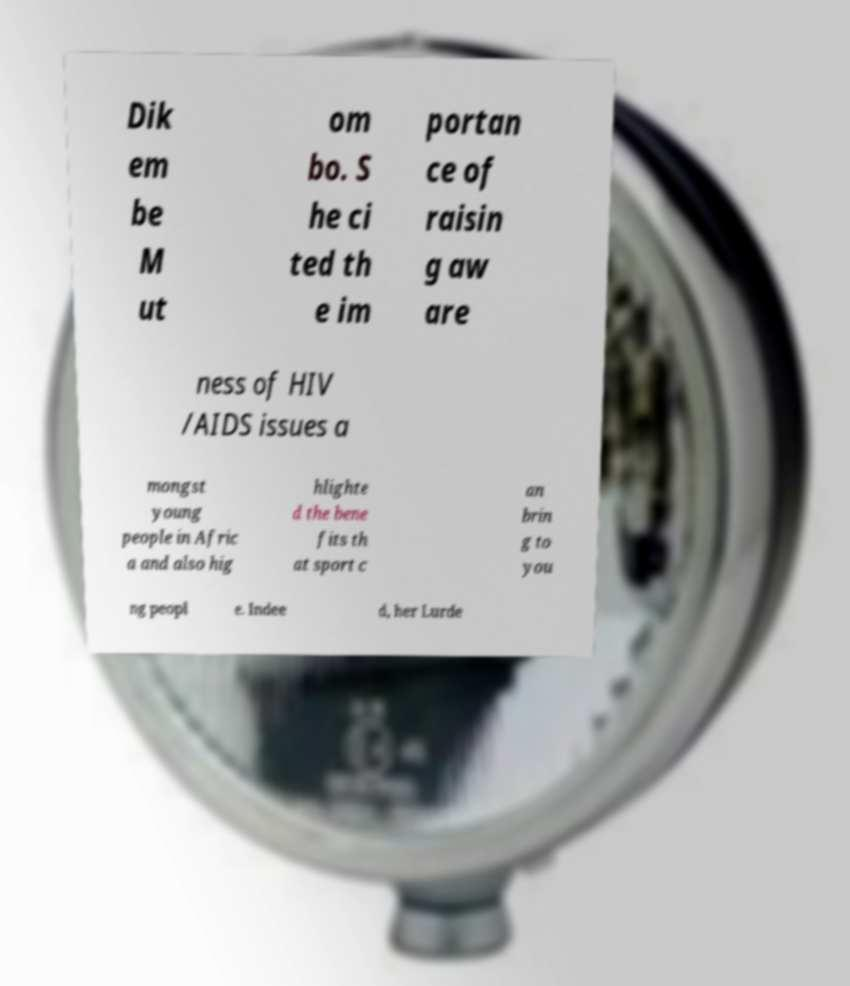Can you read and provide the text displayed in the image?This photo seems to have some interesting text. Can you extract and type it out for me? Dik em be M ut om bo. S he ci ted th e im portan ce of raisin g aw are ness of HIV /AIDS issues a mongst young people in Afric a and also hig hlighte d the bene fits th at sport c an brin g to you ng peopl e. Indee d, her Lurde 